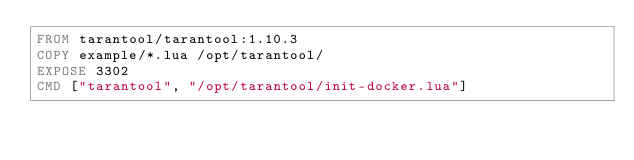<code> <loc_0><loc_0><loc_500><loc_500><_Dockerfile_>FROM tarantool/tarantool:1.10.3
COPY example/*.lua /opt/tarantool/
EXPOSE 3302
CMD ["tarantool", "/opt/tarantool/init-docker.lua"]
</code> 